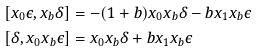Convert formula to latex. <formula><loc_0><loc_0><loc_500><loc_500>[ x _ { 0 } \epsilon , x _ { b } \delta ] & = - ( 1 + b ) x _ { 0 } x _ { b } \delta - b x _ { 1 } x _ { b } \epsilon \\ [ \delta , x _ { 0 } x _ { b } \epsilon ] & = x _ { 0 } x _ { b } \delta + b x _ { 1 } x _ { b } \epsilon</formula> 